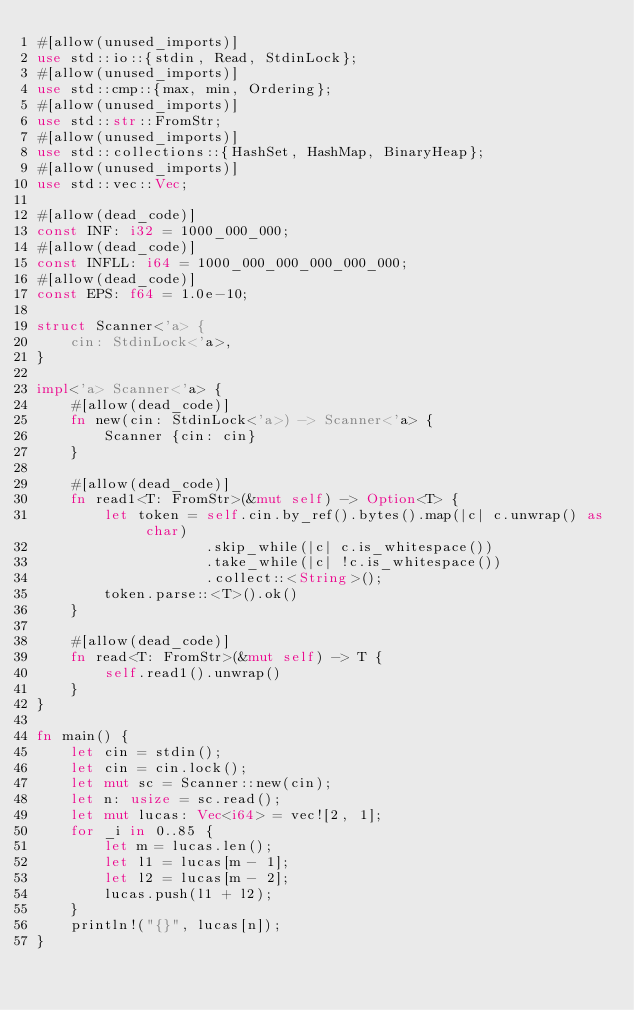Convert code to text. <code><loc_0><loc_0><loc_500><loc_500><_Rust_>#[allow(unused_imports)]
use std::io::{stdin, Read, StdinLock};
#[allow(unused_imports)]
use std::cmp::{max, min, Ordering};
#[allow(unused_imports)]
use std::str::FromStr;
#[allow(unused_imports)]
use std::collections::{HashSet, HashMap, BinaryHeap};
#[allow(unused_imports)]
use std::vec::Vec;

#[allow(dead_code)]
const INF: i32 = 1000_000_000;
#[allow(dead_code)]
const INFLL: i64 = 1000_000_000_000_000_000;
#[allow(dead_code)]
const EPS: f64 = 1.0e-10;

struct Scanner<'a> {
    cin: StdinLock<'a>,
}

impl<'a> Scanner<'a> {
    #[allow(dead_code)]
    fn new(cin: StdinLock<'a>) -> Scanner<'a> {
        Scanner {cin: cin}
    }

    #[allow(dead_code)]
    fn read1<T: FromStr>(&mut self) -> Option<T> {
        let token = self.cin.by_ref().bytes().map(|c| c.unwrap() as char)
                    .skip_while(|c| c.is_whitespace())
                    .take_while(|c| !c.is_whitespace())
                    .collect::<String>();
        token.parse::<T>().ok()
    }

    #[allow(dead_code)]
    fn read<T: FromStr>(&mut self) -> T {
        self.read1().unwrap()
    }
}

fn main() {
    let cin = stdin();
    let cin = cin.lock();
    let mut sc = Scanner::new(cin);
    let n: usize = sc.read();
    let mut lucas: Vec<i64> = vec![2, 1];
    for _i in 0..85 {
        let m = lucas.len();
        let l1 = lucas[m - 1];
        let l2 = lucas[m - 2];
        lucas.push(l1 + l2);
    }
    println!("{}", lucas[n]);
}</code> 